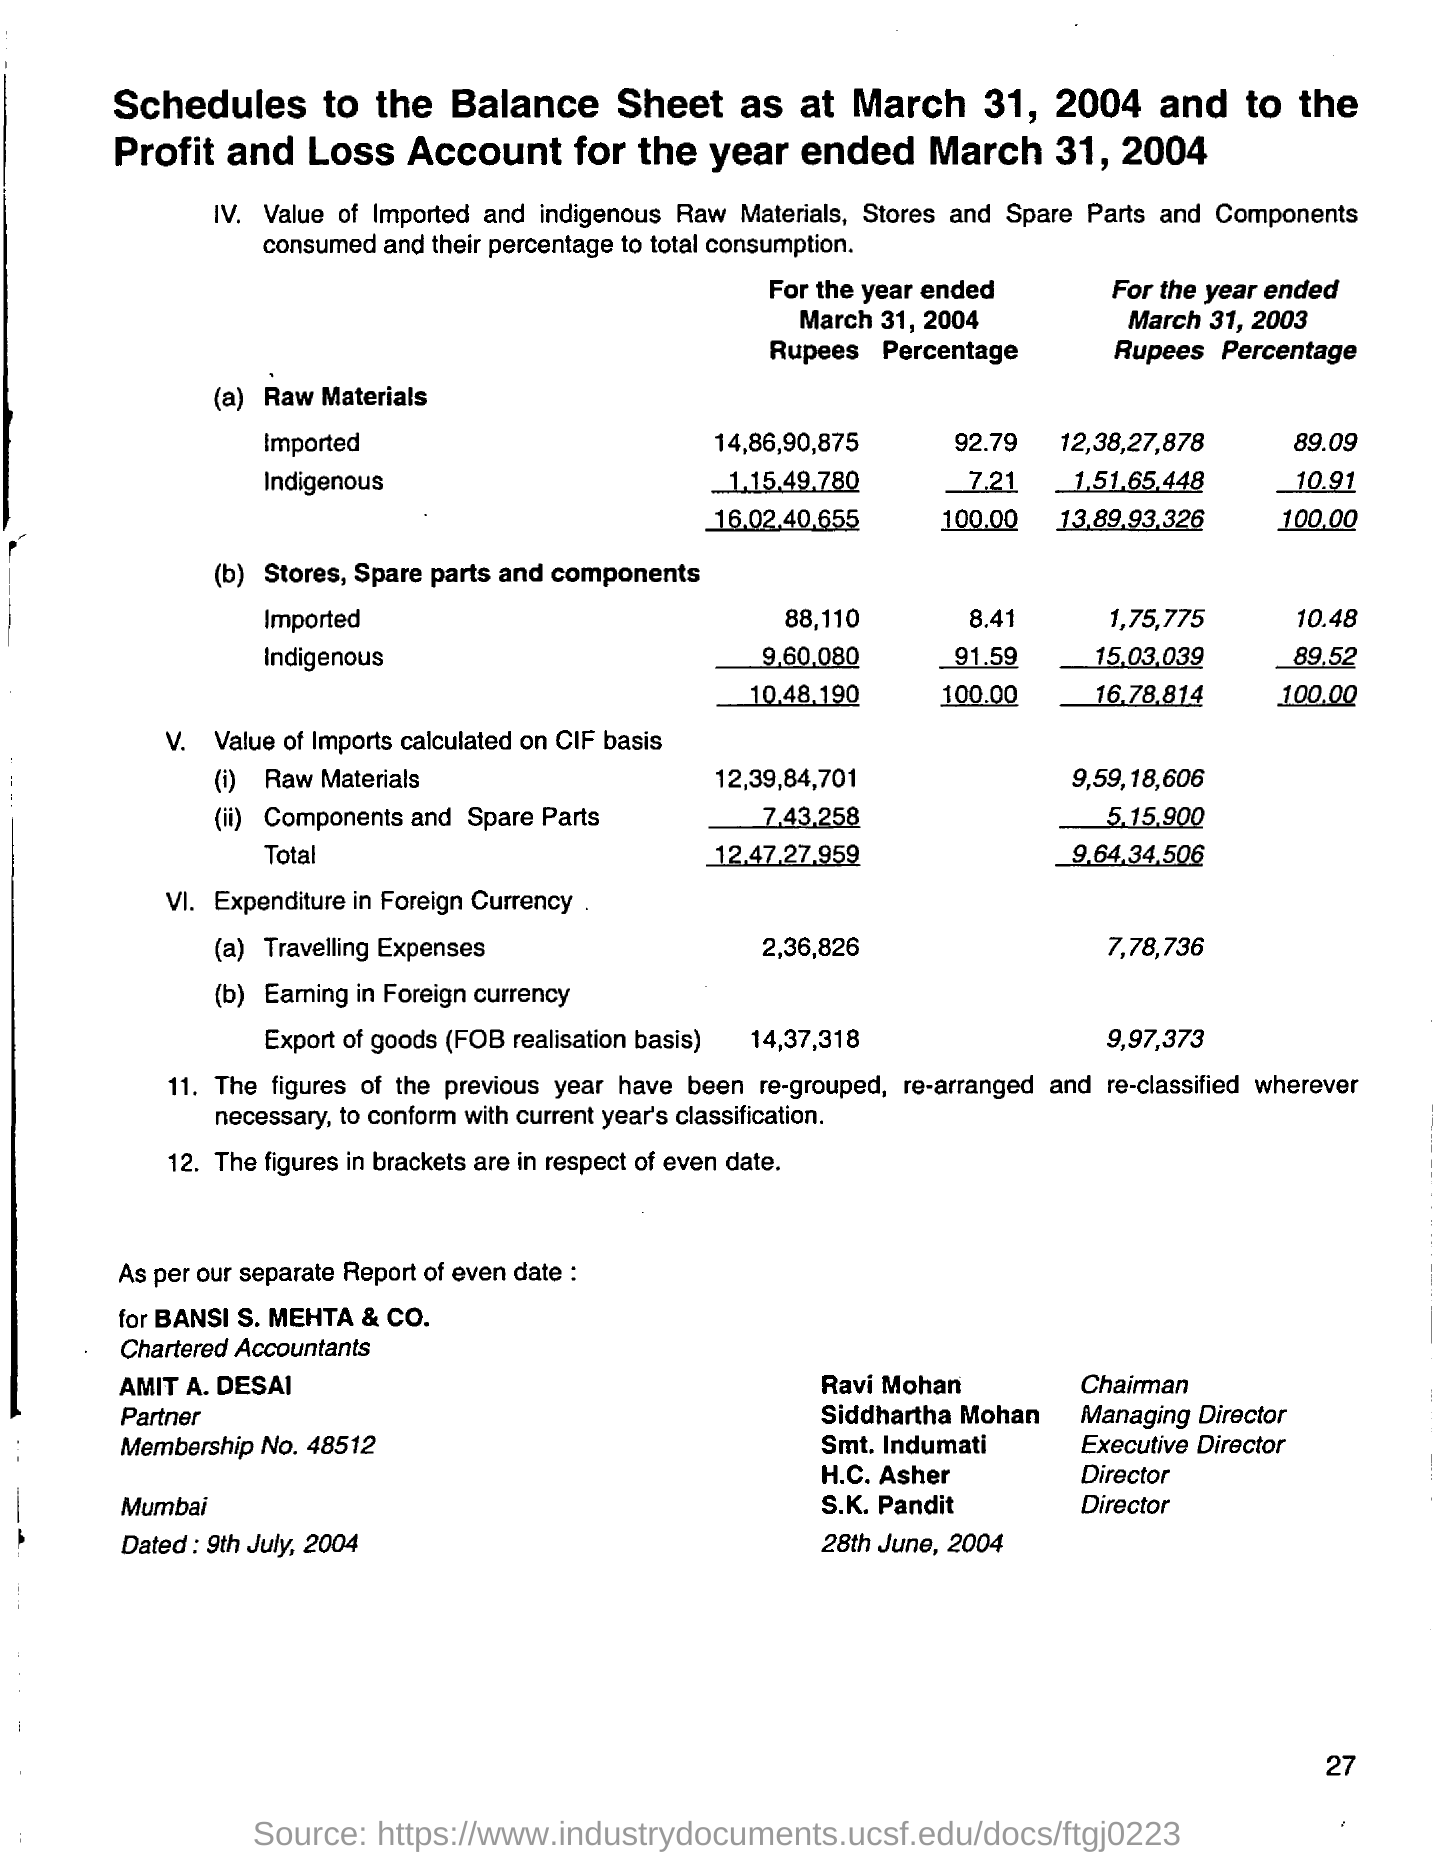Mention a couple of crucial points in this snapshot. Ravi Maohan is the chairman. The cost of indigenous raw materials for the year ended March 31, 2004, was 1,15,49,780. Bansi S. Mehta & Co.'s partner is Amit A. Desai. For the year ended March 31, 2004, approximately 92.79% of the raw materials used were imported. The total value of imports calculated on the Cost, Insurance and Freight (CIF) basis for the year ended March 31, 2004, was 12,47,27,959. 